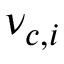Convert formula to latex. <formula><loc_0><loc_0><loc_500><loc_500>\nu _ { c , i }</formula> 